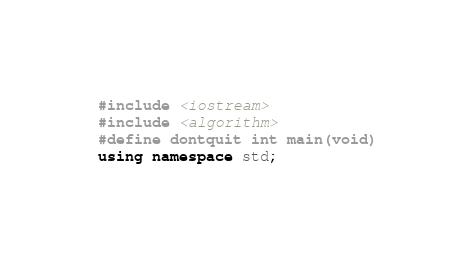Convert code to text. <code><loc_0><loc_0><loc_500><loc_500><_C++_>#include <iostream>
#include <algorithm>
#define dontquit int main(void)
using namespace std;</code> 